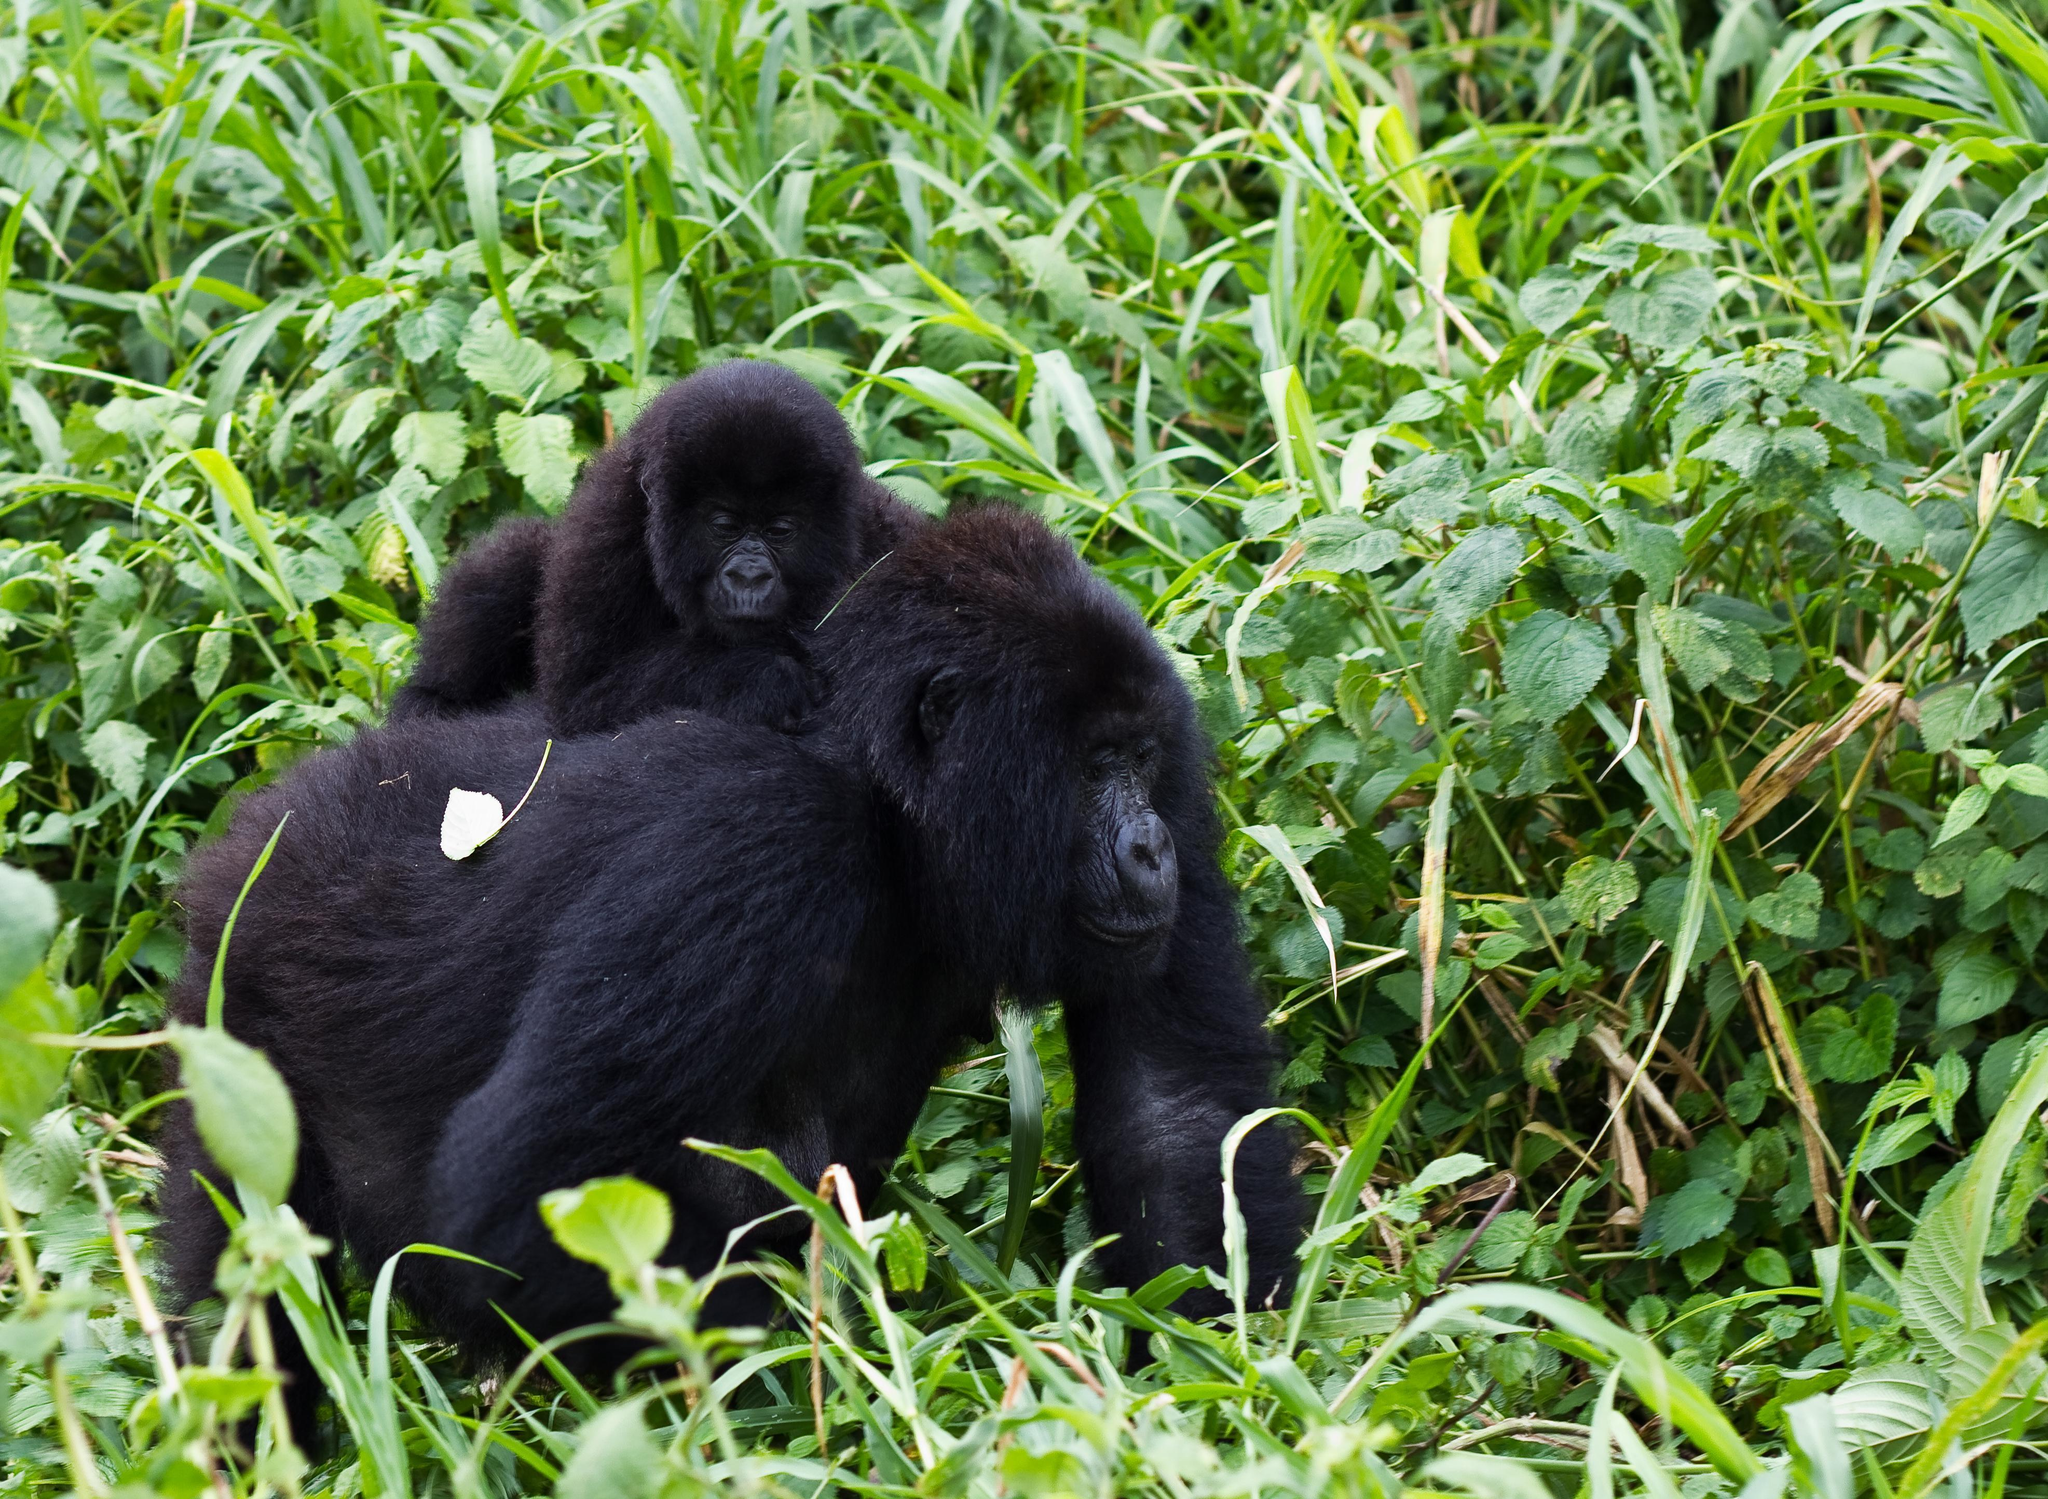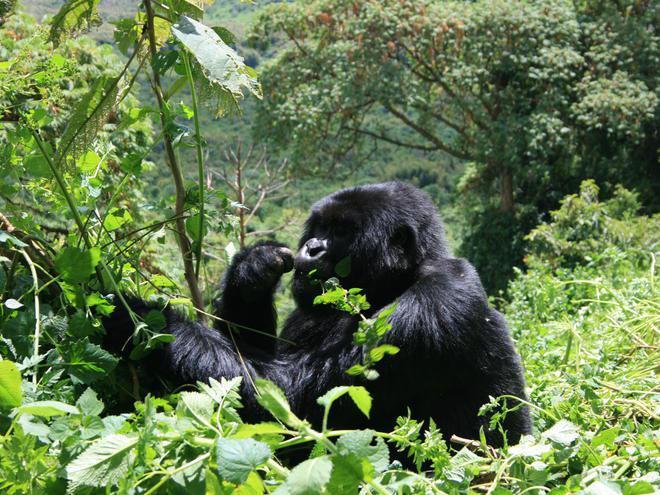The first image is the image on the left, the second image is the image on the right. Examine the images to the left and right. Is the description "The left image contains exactly two gorillas." accurate? Answer yes or no. Yes. 